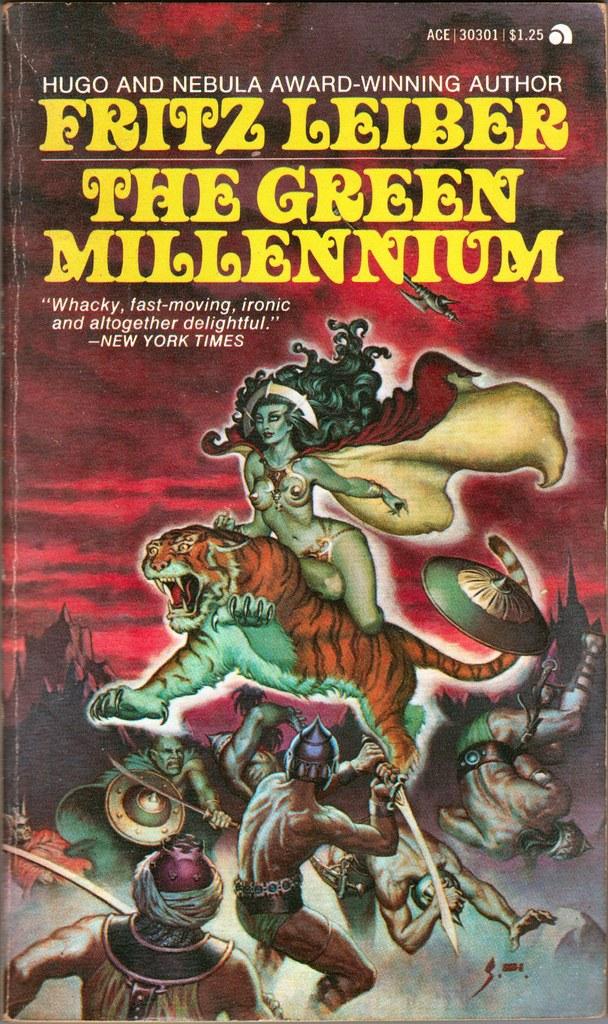What's the name of the author?
Keep it short and to the point. Fritz leiber. What is the title?
Keep it short and to the point. The green millennium. 